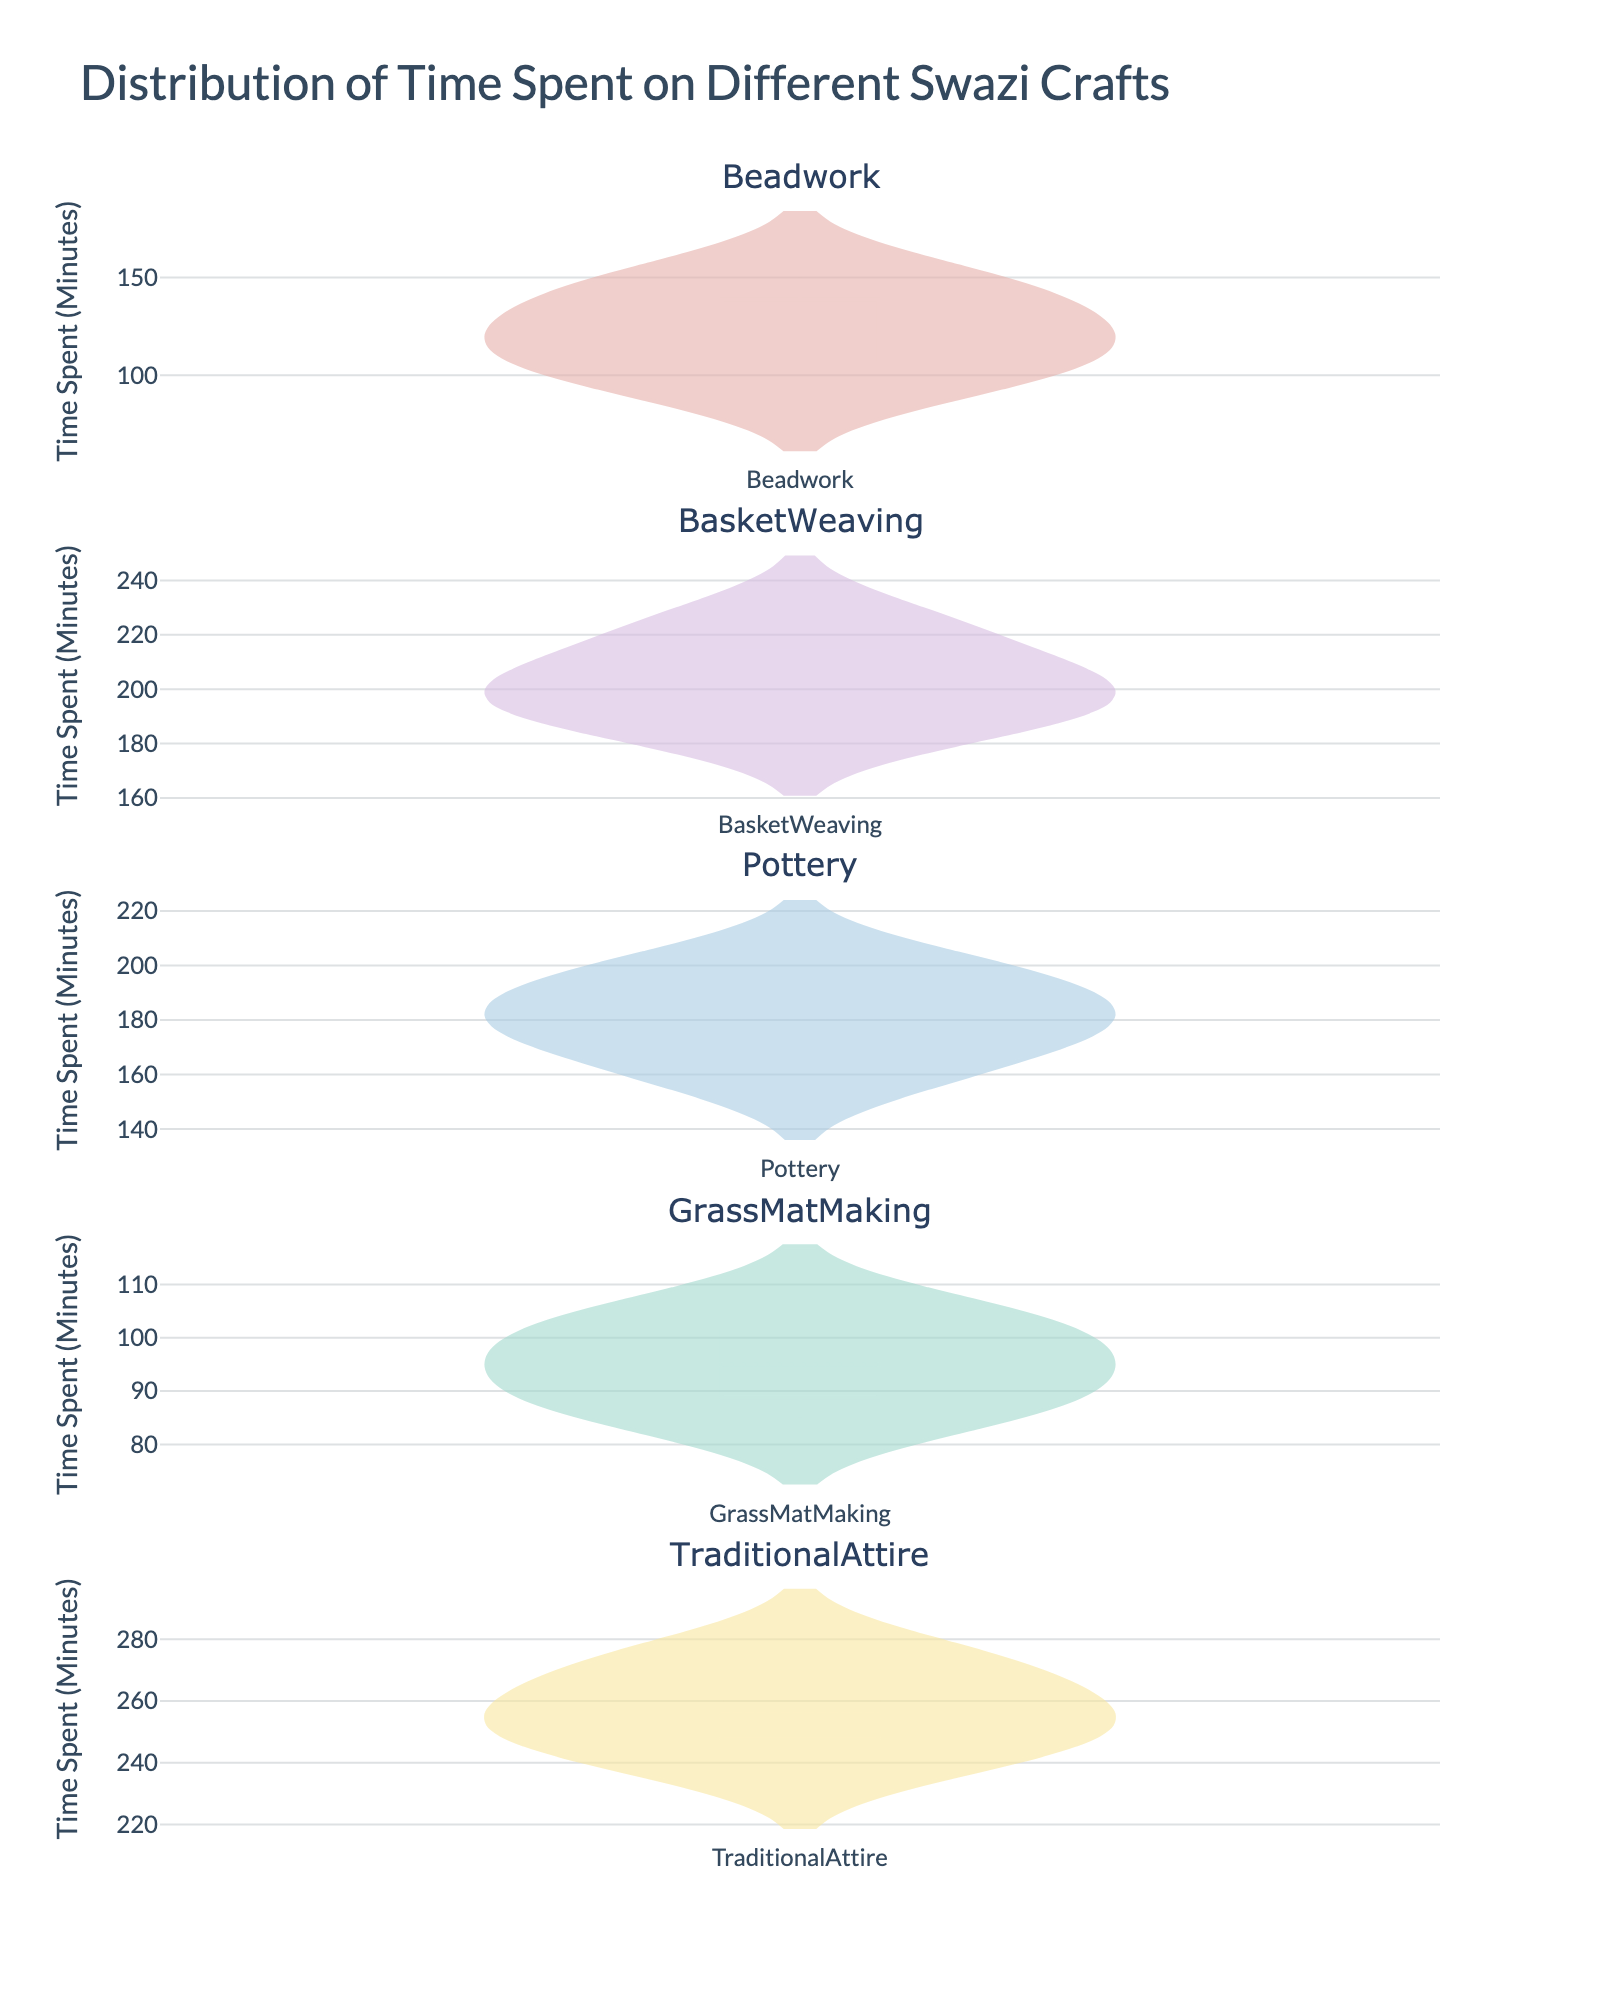What's the title of the figure? The title of the figure is usually located at the top of the plot. From the code, we see the title set as "Distribution of Time Spent on Different Swazi Crafts".
Answer: Distribution of Time Spent on Different Swazi Crafts Which craft type shows the highest median time spent? The median is represented by the line within the box of each violin plot. From the figure, the highest median line is observed in the "Traditional Attire" plot.
Answer: Traditional Attire How does the range of time spent on beadwork compare to that of basket weaving? The range can be determined by looking at the length of the violin plots from the lowest to the highest value. Beadwork ranges from about 95 to 150 minutes, while basket weaving ranges from about 185 to 225 minutes. Basket weaving has a larger range.
Answer: Basket weaving has a larger range than beadwork What is the mean time spent on pottery? The mean is typically indicated by a dashed line in a violin plot. From the figure, observe the dashed line in the "Pottery" plot to find its position.
Answer: Approximately 181 minutes Which craft type has the lowest variability in time spent? Variability can be judged by the width of the violin plots. The narrower the plot, the lower the variability. The "GrassMatMaking" plot is the narrowest, indicating the lowest variability.
Answer: GrassMatMaking What's the range of time spent on traditional attire? The range is the difference between the maximum and minimum values. From the figure, Traditional Attire ranges from about 240 to 275 minutes. Calculate the range: 275 - 240 = 35 minutes.
Answer: 35 minutes Which craft type has the most data points within its distribution? By observing the density and number of points in each violin plot, we see that all types appear to have exactly 5 data points each, as they all appear with similar density columns within the plots.
Answer: All crafts have equal data points (5 each) Compare the upper quartile (75th percentile) of grass mat making and beadwork. The 75th percentile is where the upper part of the box ends in each violin plot. In "GrassMatMaking," it is about 105 minutes, and in "Beadwork," it is about 135 minutes.
Answer: Beadwork has a higher upper quartile than GrassMatMaking Which craft type shows the largest interquartile range (IQR)? The IQR is the distance between the 25th and 75th percentiles, represented by the box in the violin plot. By comparing each plot, the largest IQR appears in "BasketWeaving".
Answer: Basket Weaving 